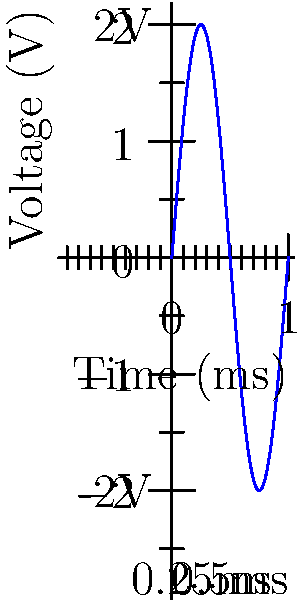As an artist familiar with visual patterns, analyze the waveform displayed on this oscilloscope. What is the peak-to-peak voltage and frequency of this sinusoidal signal? To determine the peak-to-peak voltage and frequency of the sinusoidal signal, let's follow these steps:

1. Peak-to-peak voltage:
   - The peak-to-peak voltage is the difference between the maximum and minimum points of the waveform.
   - From the y-axis labels, we can see that the maximum point is at 2V and the minimum is at -2V.
   - Therefore, the peak-to-peak voltage is: $V_{pp} = 2V - (-2V) = 4V$

2. Frequency:
   - The frequency is the inverse of the period (time for one complete cycle).
   - From the x-axis, we can see that one complete cycle takes 0.5 ms.
   - The period (T) is thus 0.5 ms or $0.5 \times 10^{-3}$ seconds.
   - The frequency (f) is calculated using the formula: $f = \frac{1}{T}$
   - $f = \frac{1}{0.5 \times 10^{-3}} = 2000$ Hz or 2 kHz

Therefore, the peak-to-peak voltage is 4V, and the frequency is 2 kHz.
Answer: 4V, 2 kHz 